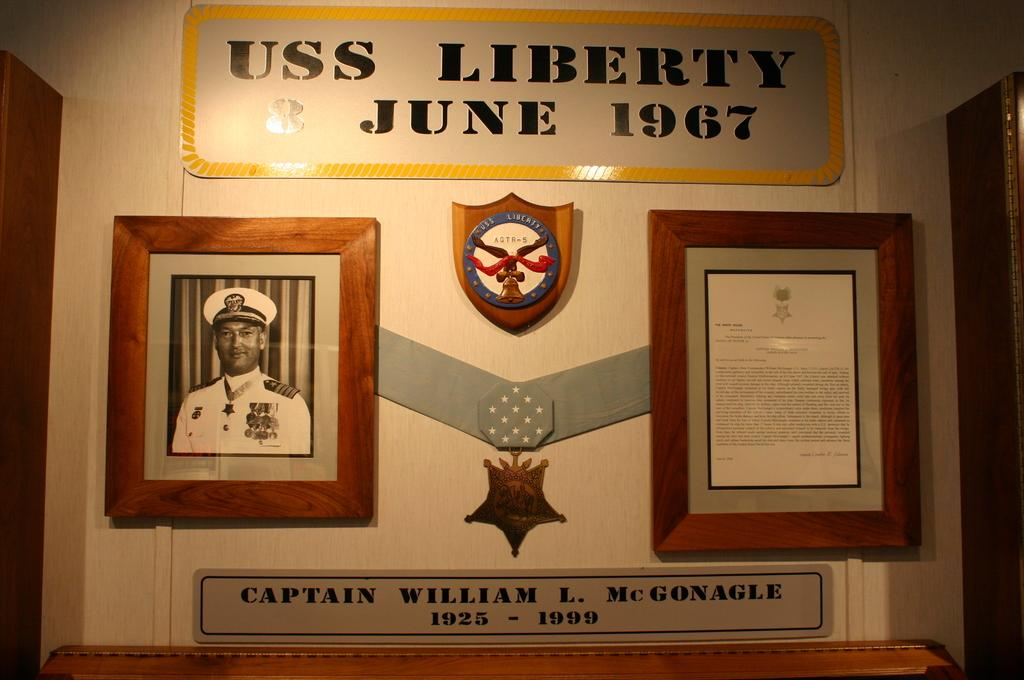Provide a one-sentence caption for the provided image. A plaque on the wall for Captain William L. McGonagle describes his time with USS Liberty in June 1967. 